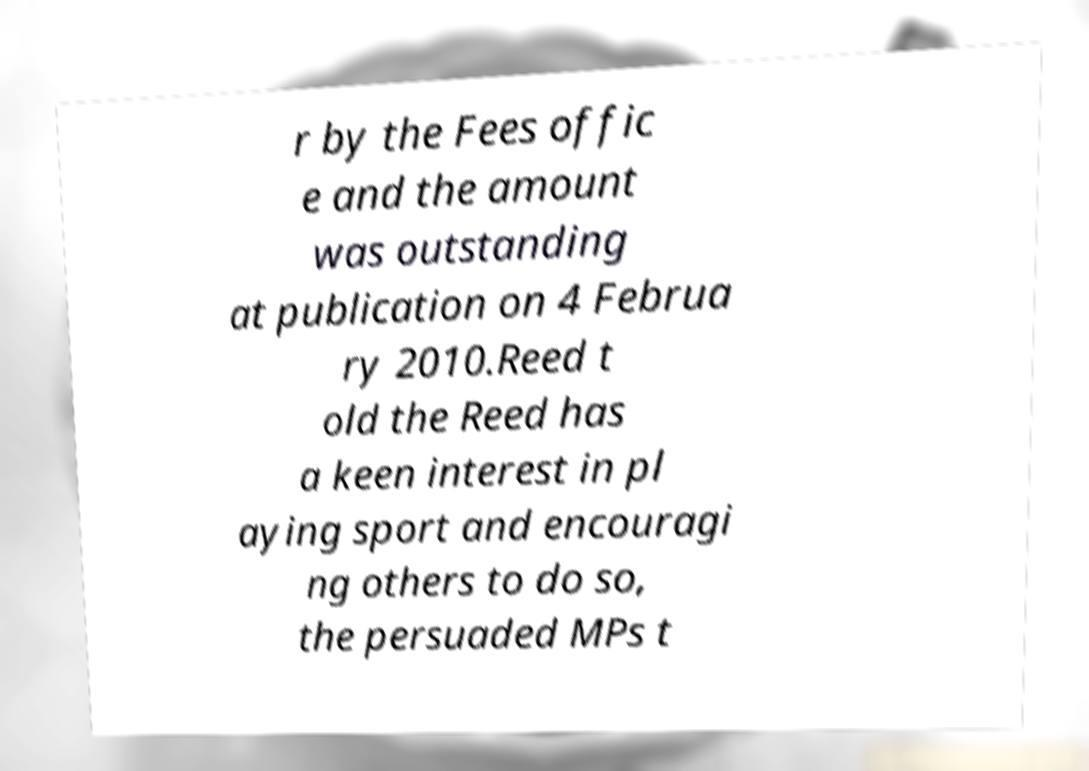There's text embedded in this image that I need extracted. Can you transcribe it verbatim? r by the Fees offic e and the amount was outstanding at publication on 4 Februa ry 2010.Reed t old the Reed has a keen interest in pl aying sport and encouragi ng others to do so, the persuaded MPs t 